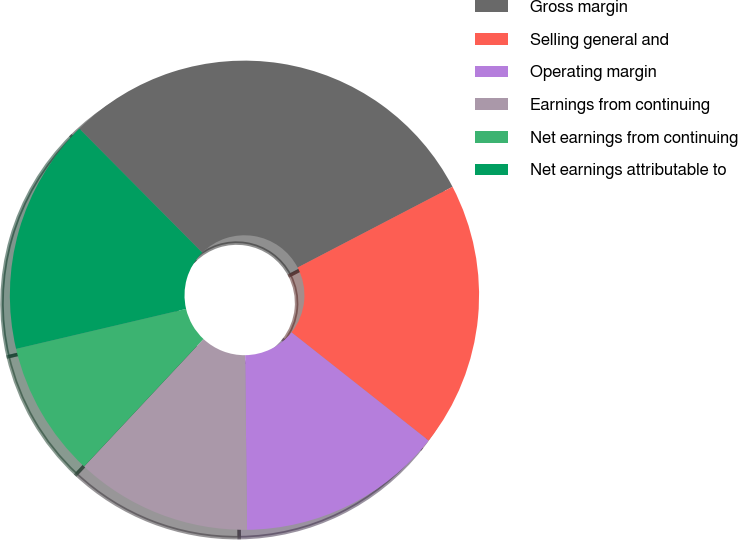Convert chart. <chart><loc_0><loc_0><loc_500><loc_500><pie_chart><fcel>Gross margin<fcel>Selling general and<fcel>Operating margin<fcel>Earnings from continuing<fcel>Net earnings from continuing<fcel>Net earnings attributable to<nl><fcel>29.78%<fcel>18.28%<fcel>14.19%<fcel>12.15%<fcel>9.35%<fcel>16.24%<nl></chart> 